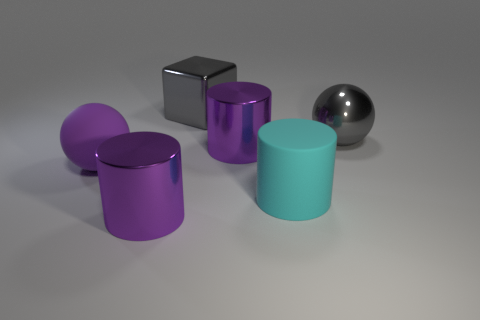What is the material of the large gray block that is behind the large rubber object to the right of the ball that is in front of the large gray metallic ball?
Provide a short and direct response. Metal. What number of cyan objects are either large shiny blocks or rubber balls?
Offer a very short reply. 0. What is the size of the purple metal cylinder in front of the rubber object in front of the large rubber thing that is behind the cyan rubber object?
Your answer should be compact. Large. What is the size of the gray metallic thing that is the same shape as the big purple matte thing?
Keep it short and to the point. Large. What number of large objects are either purple cylinders or cyan rubber cylinders?
Your response must be concise. 3. Is the purple thing that is in front of the cyan matte object made of the same material as the large sphere to the right of the big cyan thing?
Keep it short and to the point. Yes. What is the ball that is behind the purple rubber thing made of?
Offer a terse response. Metal. How many matte objects are big cyan objects or small cyan objects?
Give a very brief answer. 1. There is a rubber object left of the gray shiny object left of the large cyan matte object; what color is it?
Give a very brief answer. Purple. Is the cyan thing made of the same material as the big purple thing behind the large rubber ball?
Give a very brief answer. No. 